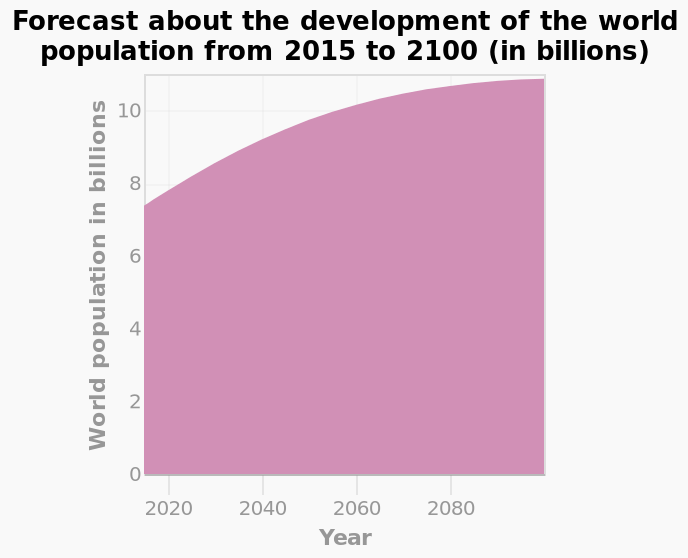<image>
What is the scale range along the x-axis? The scale range along the x-axis is from 2020 to 2080. What is the title of the area plot? The area plot is named "Forecast about the development of the world population from 2015 to 2100 (in billions)." please summary the statistics and relations of the chart from 2020 to 2100 the population has gradually increased, it seems to be increasing about a billion each year. please enumerates aspects of the construction of the chart This area plot is named Forecast about the development of the world population from 2015 to 2100 (in billions). A linear scale of range 2020 to 2080 can be seen along the x-axis, labeled Year. World population in billions is shown using a linear scale of range 0 to 10 along the y-axis. 